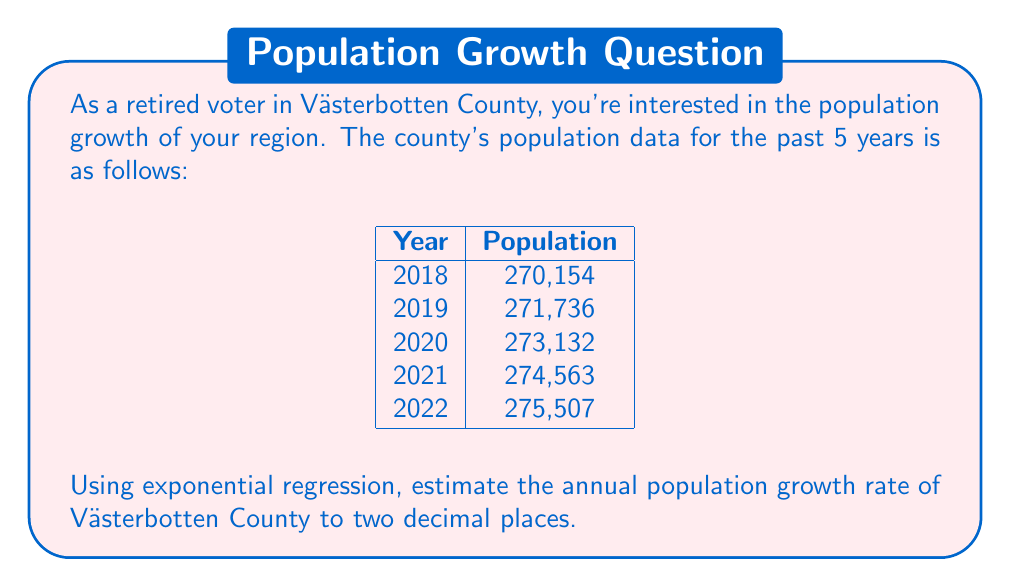Teach me how to tackle this problem. To estimate the population growth rate using exponential regression, we'll follow these steps:

1) The exponential growth model is given by $P(t) = P_0 e^{rt}$, where $P_0$ is the initial population, $r$ is the growth rate, and $t$ is the time in years.

2) Taking the natural logarithm of both sides:
   $\ln(P(t)) = \ln(P_0) + rt$

3) This is now in the form of a linear equation $y = mx + b$, where:
   $y = \ln(P(t))$, $x = t$, $m = r$, and $b = \ln(P_0)$

4) We'll use the following substitutions:
   $x_i = $ years since 2018 (0, 1, 2, 3, 4)
   $y_i = \ln(\text{population})$

5) Calculate the following sums:
   $\sum x_i = 0 + 1 + 2 + 3 + 4 = 10$
   $\sum x_i^2 = 0^2 + 1^2 + 2^2 + 3^2 + 4^2 = 30$
   $\sum y_i = \ln(270154) + \ln(271736) + \ln(273132) + \ln(274563) + \ln(275507) = 61.8246$
   $\sum x_iy_i = 0\ln(270154) + 1\ln(271736) + 2\ln(273132) + 3\ln(274563) + 4\ln(275507) = 247.4925$

6) Use the formula for the slope (which is our growth rate $r$):
   $$r = \frac{n\sum x_iy_i - \sum x_i \sum y_i}{n\sum x_i^2 - (\sum x_i)^2}$$

   Where $n = 5$ (number of data points)

7) Plugging in the values:
   $$r = \frac{5(247.4925) - 10(61.8246)}{5(30) - 10^2} = 0.004769$$

8) Convert to a percentage by multiplying by 100 and rounding to two decimal places.
Answer: 0.48% 